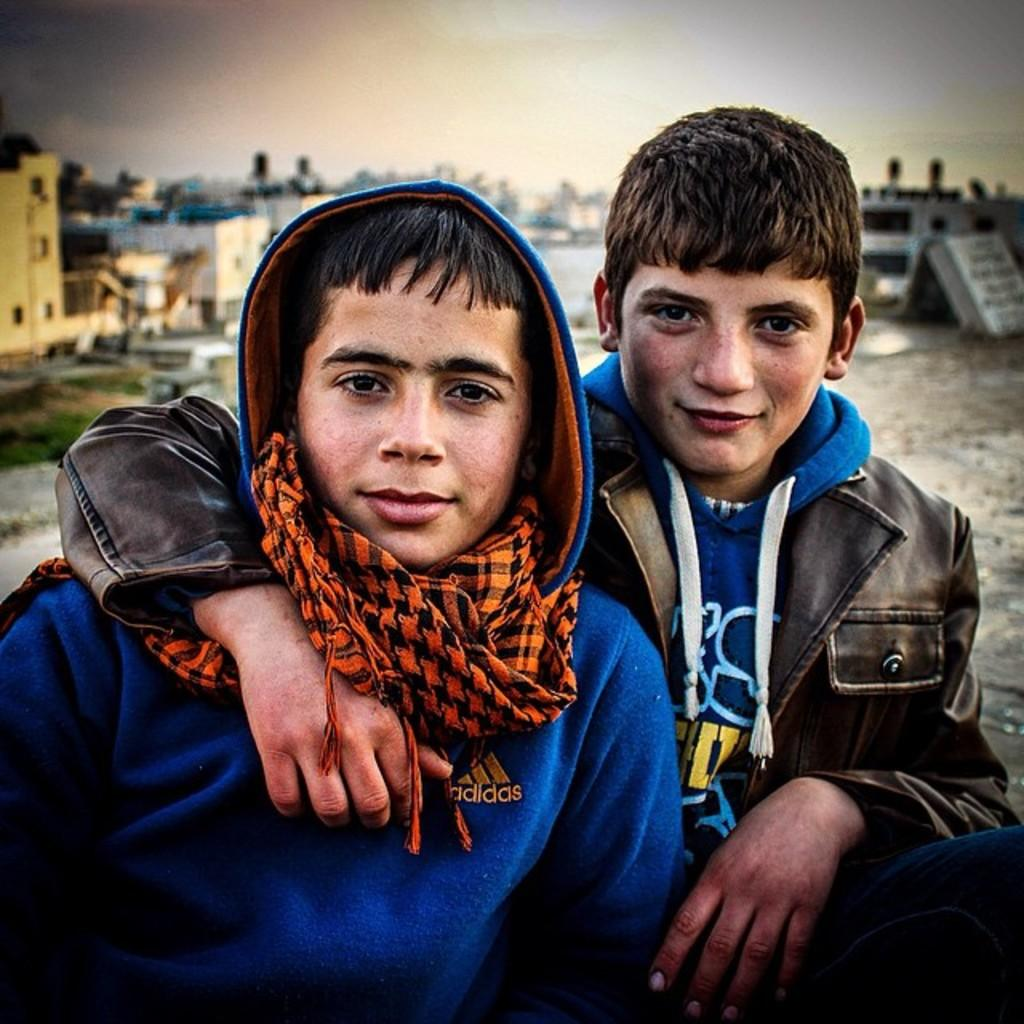How many people are present in the image? There are two persons in the image. What can be seen in the background of the image? There are buildings and the sky visible in the background of the image. What type of cat can be seen playing a guitar in the image? There is no cat or guitar present in the image. 